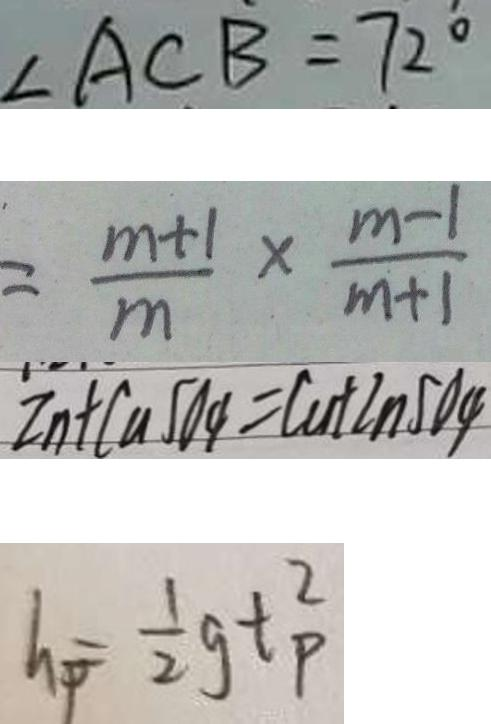<formula> <loc_0><loc_0><loc_500><loc_500>\angle A C B = 7 2 ^ { \circ } 
 = \frac { m + 1 } { m } \times \frac { m - 1 } { m + 1 } 
 Z n + C u S O _ { 4 } = C u + 2 n S O _ { 4 } 
 h _ { p } = \frac { 1 } { 2 } g t _ { P } ^ { 2 }</formula> 